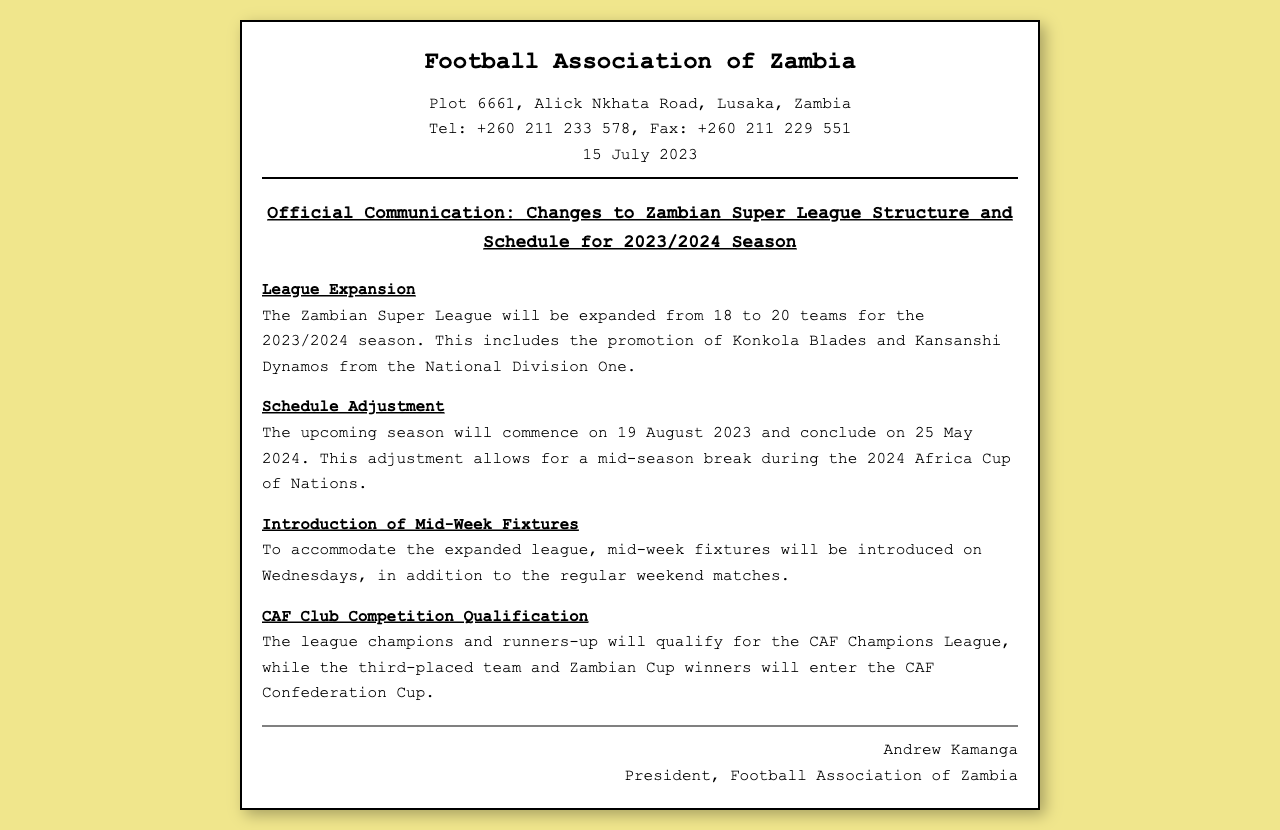What date does the 2023/2024 season commence? The document states the upcoming season will commence on 19 August 2023.
Answer: 19 August 2023 How many teams will be in the Zambian Super League for the upcoming season? The document mentions the league will expand from 18 to 20 teams.
Answer: 20 teams Which teams are promoted to the Zambian Super League? According to the document, Konkola Blades and Kansanshi Dynamos are promoted.
Answer: Konkola Blades and Kansanshi Dynamos What is introduced to the league schedule to accommodate its expansion? The document states mid-week fixtures will be introduced on Wednesdays.
Answer: Mid-week fixtures When does the season conclude? The document specifies the season will conclude on 25 May 2024.
Answer: 25 May 2024 Who is the president of the Football Association of Zambia? The document lists Andrew Kamanga as the president.
Answer: Andrew Kamanga What competitions will the league champions qualify for? The document mentions the league champions will qualify for the CAF Champions League.
Answer: CAF Champions League What is the purpose of the mid-season break mentioned in the document? The document states the break allows for the 2024 Africa Cup of Nations.
Answer: 2024 Africa Cup of Nations 